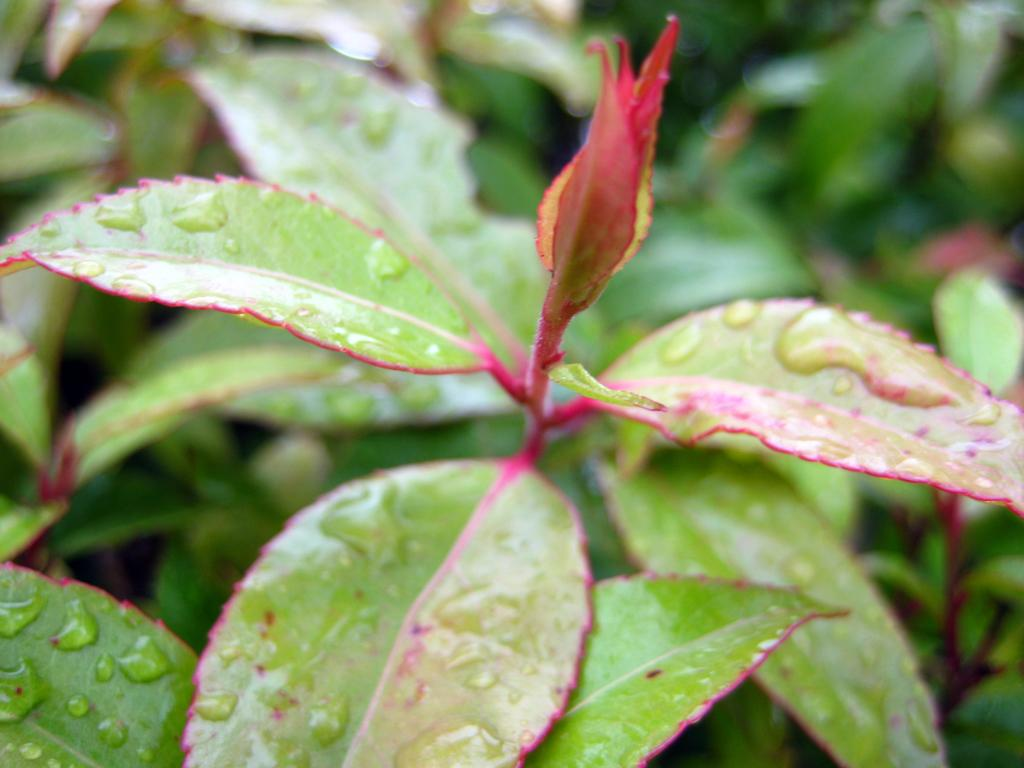What can be seen on the leaves in the image? There are water droplets on the leaves in the image. How would you describe the background of the image? The background of the image is blurred. What type of pollution can be seen in the image? There is no pollution present in the image; it features water droplets on leaves with a blurred background. What color are the teeth of the person in the image? There is no person present in the image, so their teeth cannot be observed. 